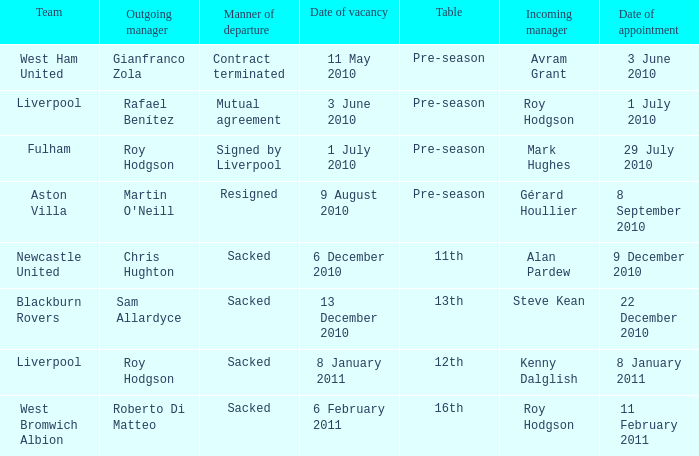What team has an incoming manager named Kenny Dalglish? Liverpool. 